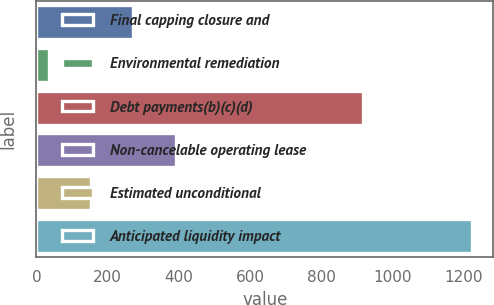Convert chart. <chart><loc_0><loc_0><loc_500><loc_500><bar_chart><fcel>Final capping closure and<fcel>Environmental remediation<fcel>Debt payments(b)(c)(d)<fcel>Non-cancelable operating lease<fcel>Estimated unconditional<fcel>Anticipated liquidity impact<nl><fcel>272.4<fcel>35<fcel>916<fcel>391.1<fcel>153.7<fcel>1222<nl></chart> 